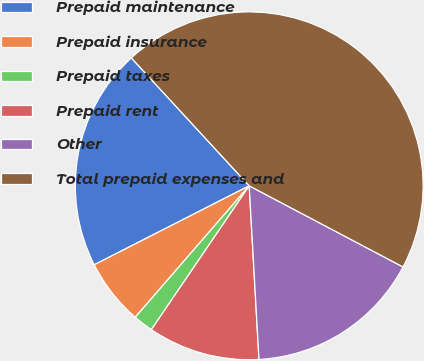<chart> <loc_0><loc_0><loc_500><loc_500><pie_chart><fcel>Prepaid maintenance<fcel>Prepaid insurance<fcel>Prepaid taxes<fcel>Prepaid rent<fcel>Other<fcel>Total prepaid expenses and<nl><fcel>20.65%<fcel>6.13%<fcel>1.86%<fcel>10.4%<fcel>16.38%<fcel>44.57%<nl></chart> 